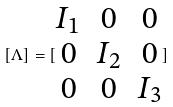<formula> <loc_0><loc_0><loc_500><loc_500>[ \Lambda ] = [ \begin{matrix} I _ { 1 } & 0 & 0 \\ 0 & I _ { 2 } & 0 \\ 0 & 0 & I _ { 3 } \end{matrix} ]</formula> 